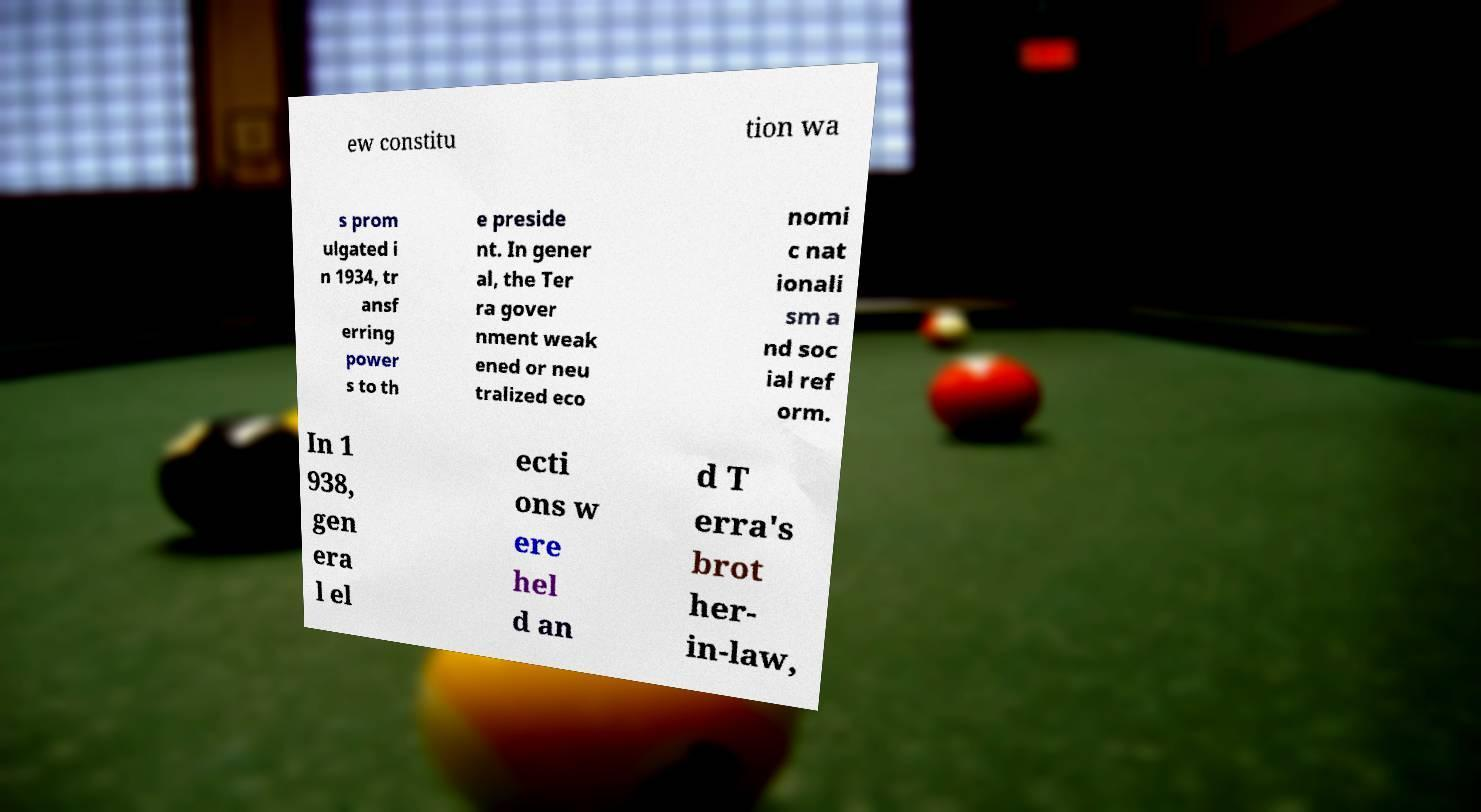Could you assist in decoding the text presented in this image and type it out clearly? ew constitu tion wa s prom ulgated i n 1934, tr ansf erring power s to th e preside nt. In gener al, the Ter ra gover nment weak ened or neu tralized eco nomi c nat ionali sm a nd soc ial ref orm. In 1 938, gen era l el ecti ons w ere hel d an d T erra's brot her- in-law, 